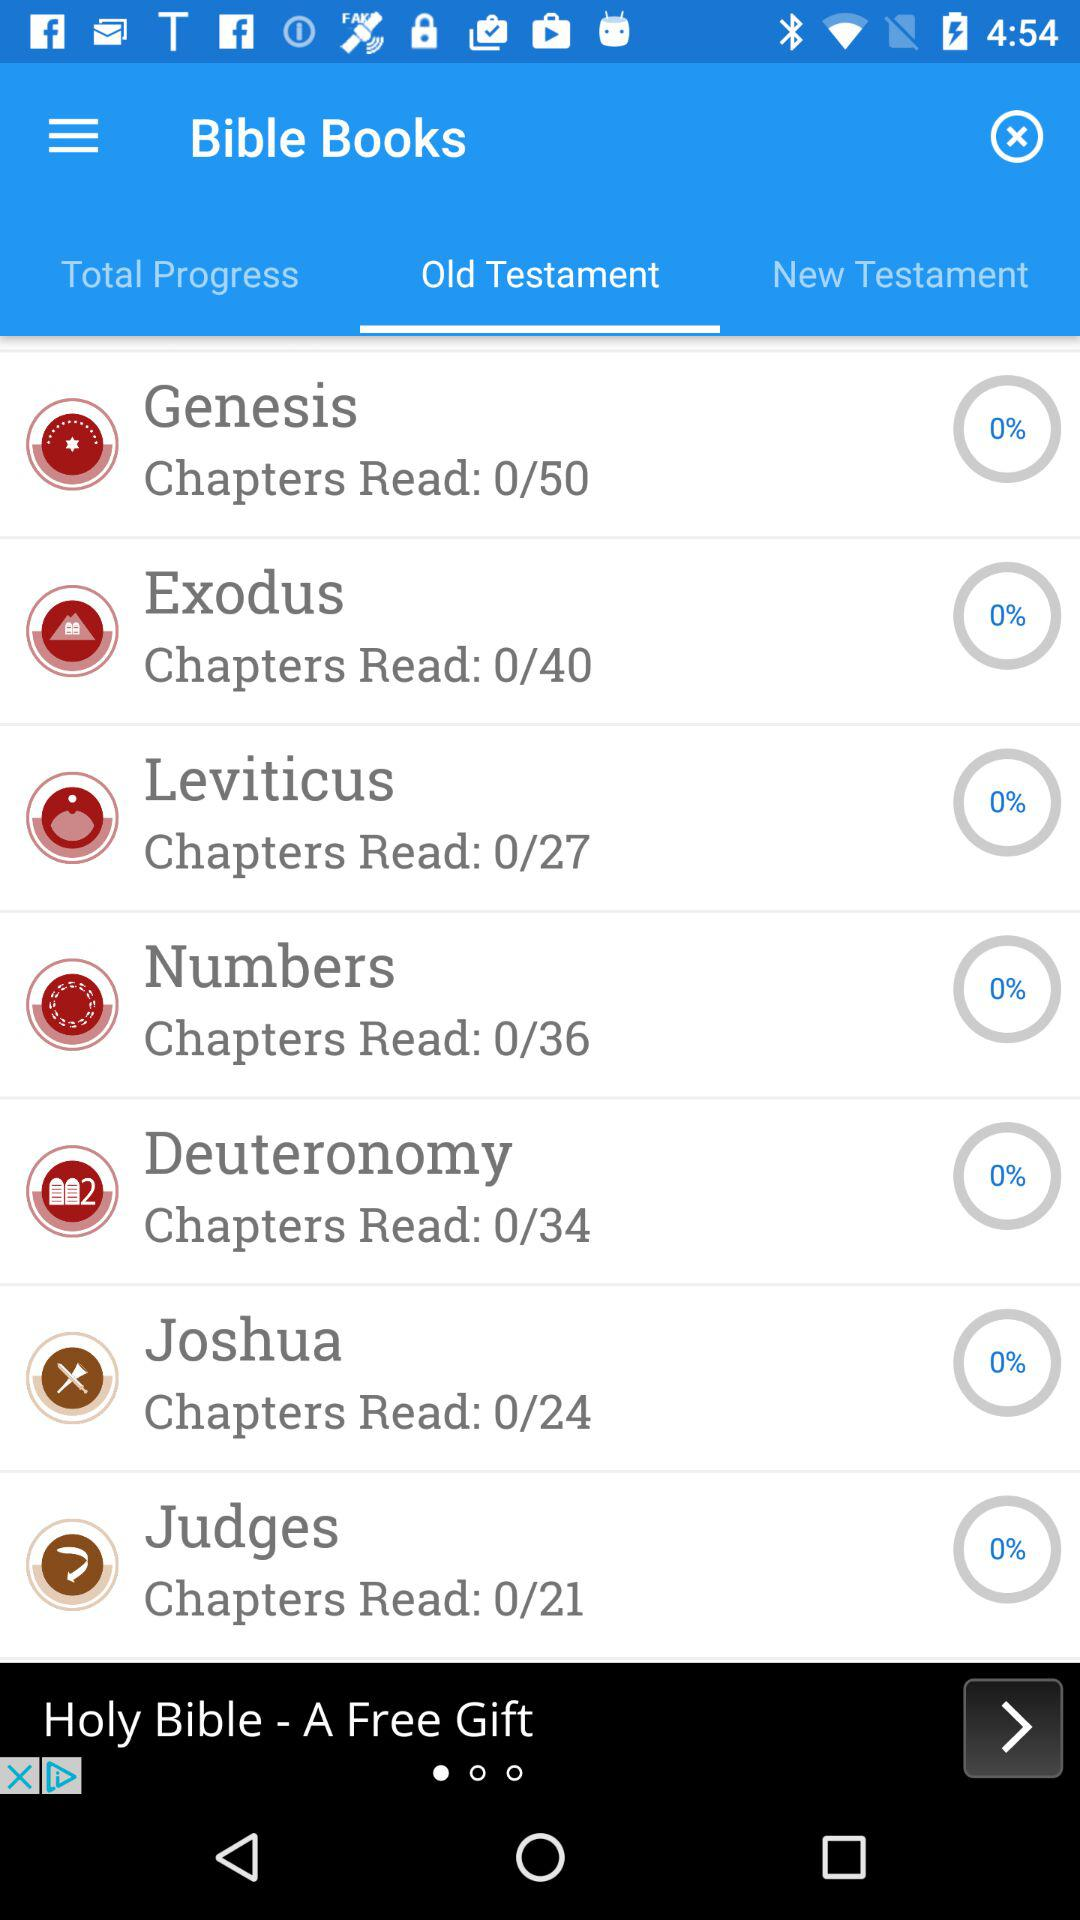Which tab is selected? The selected tab is "Old Testament". 